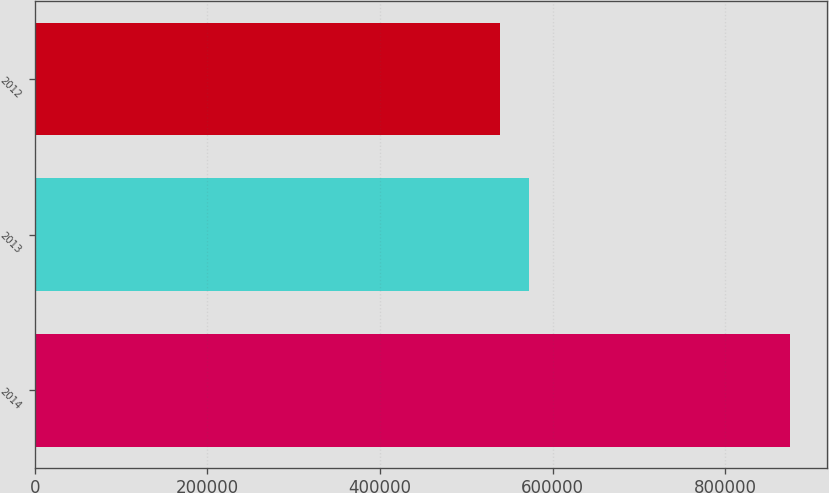<chart> <loc_0><loc_0><loc_500><loc_500><bar_chart><fcel>2014<fcel>2013<fcel>2012<nl><fcel>874592<fcel>573013<fcel>539504<nl></chart> 